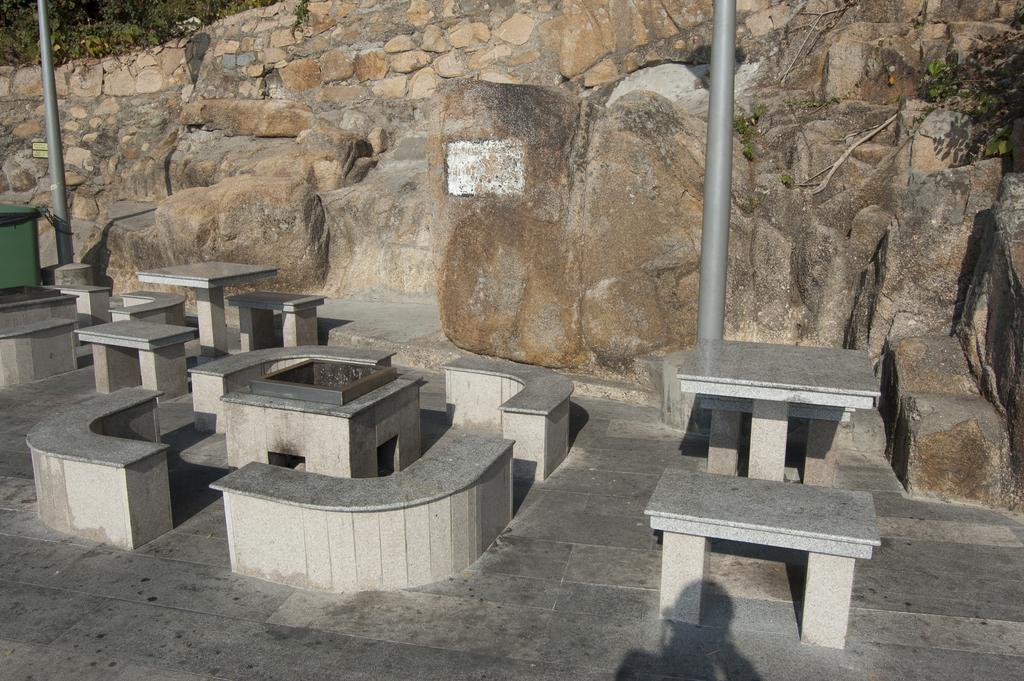Can you describe this image briefly? In this image there are concrete benches and tables, behind the benches there are two poles, rocks and trees. 